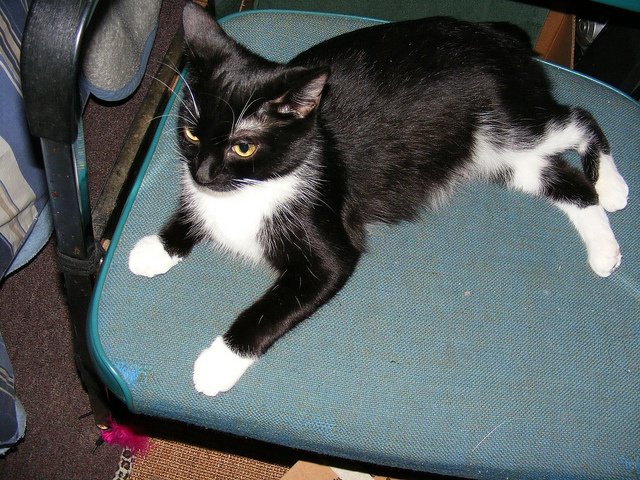Describe the objects in this image and their specific colors. I can see chair in black, gray, and darkgray tones and cat in black, white, gray, and darkgray tones in this image. 